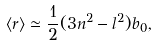Convert formula to latex. <formula><loc_0><loc_0><loc_500><loc_500>\langle r \rangle \simeq \frac { 1 } { 2 } ( 3 n ^ { 2 } - l ^ { 2 } ) b _ { 0 } ,</formula> 